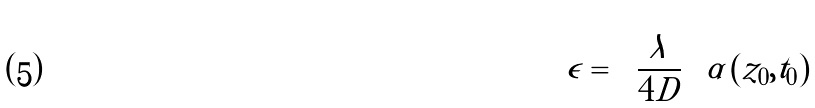<formula> <loc_0><loc_0><loc_500><loc_500>\epsilon = \left \{ \frac { \lambda } { 4 D } \right \} \alpha \left ( z _ { 0 } , t _ { 0 } \right )</formula> 